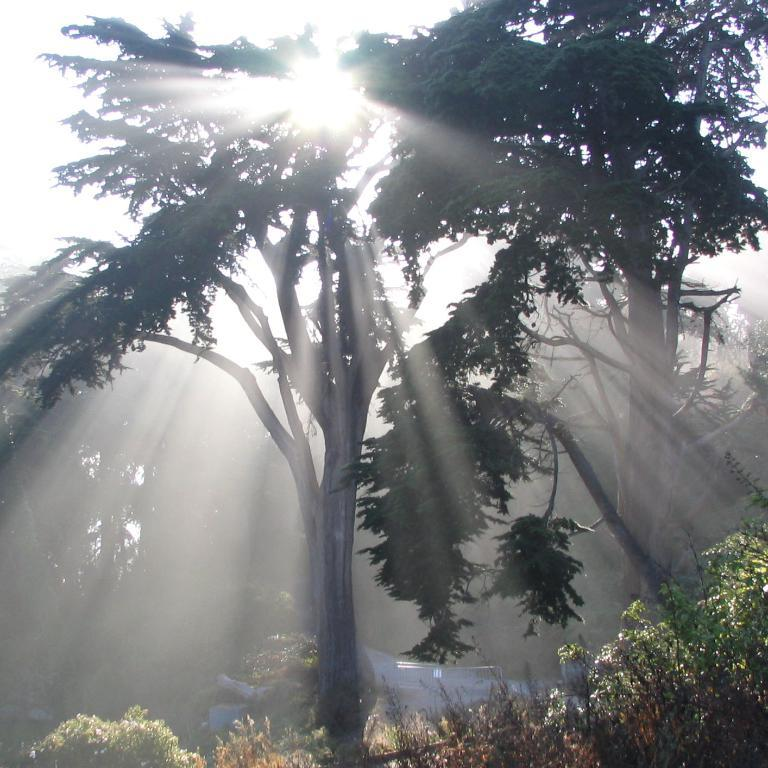What is the main subject in the center of the image? There is a tree in the center of the image. What other vegetation can be seen at the bottom of the image? There are plants at the bottom of the image. What celestial body is visible in the image? The sun is visible in the image. What type of silver object can be seen hanging from the tree in the image? There is no silver object hanging from the tree in the image. Can you spot a rabbit or bun in the image? There is no rabbit or bun present in the image. 